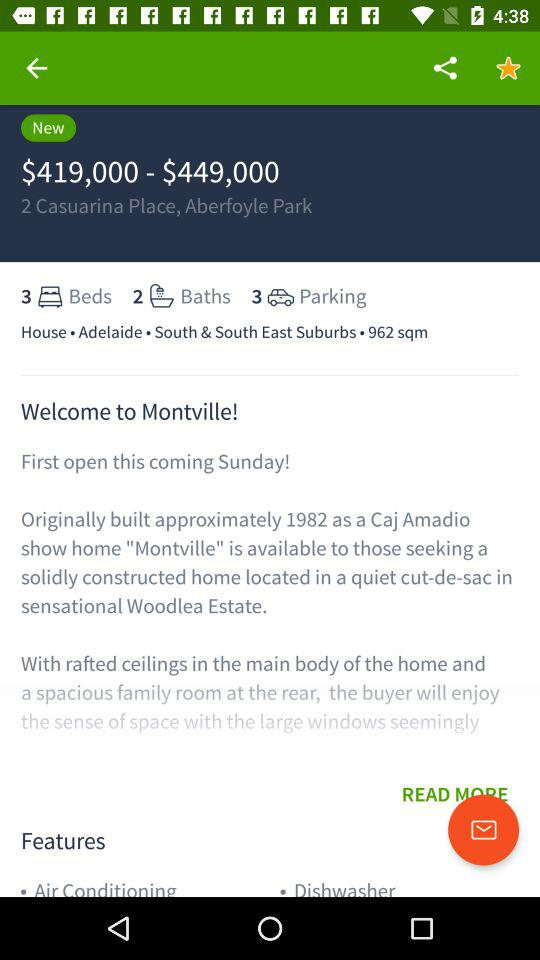What is the currency for the given price? The currency for the given price is the dollar. 